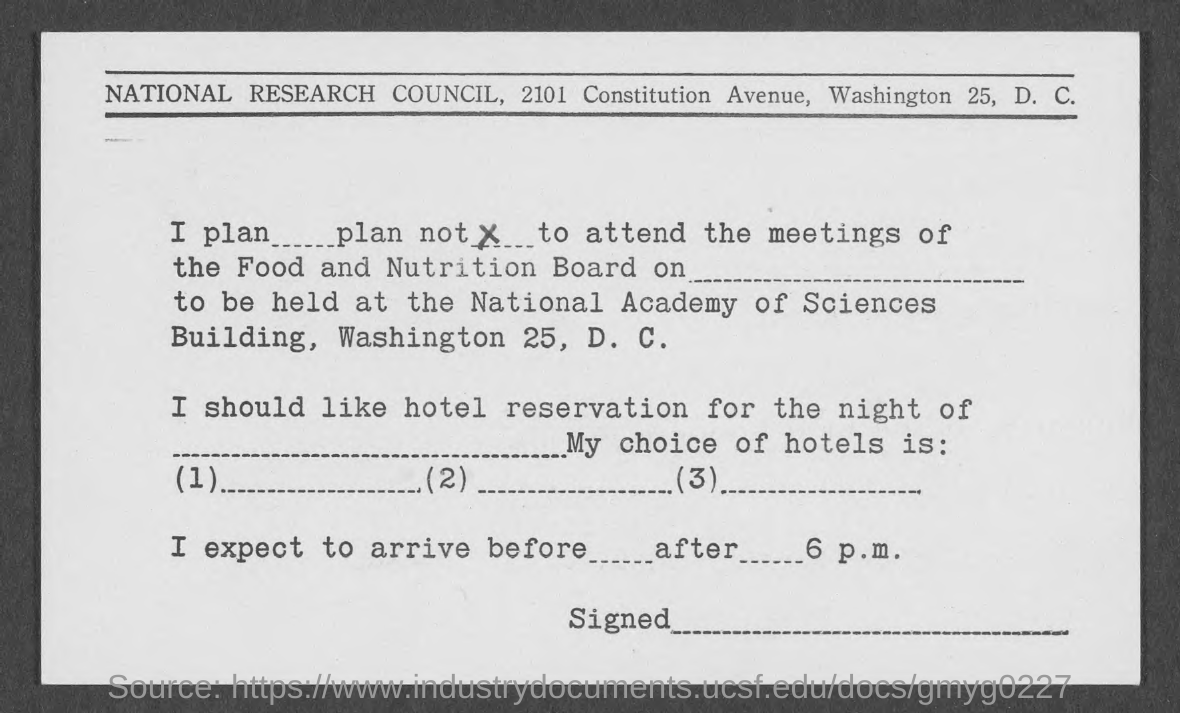Which organization is mentioned in the header of the document?
Offer a terse response. NATIONAL RESEARCH COUNCIL. 